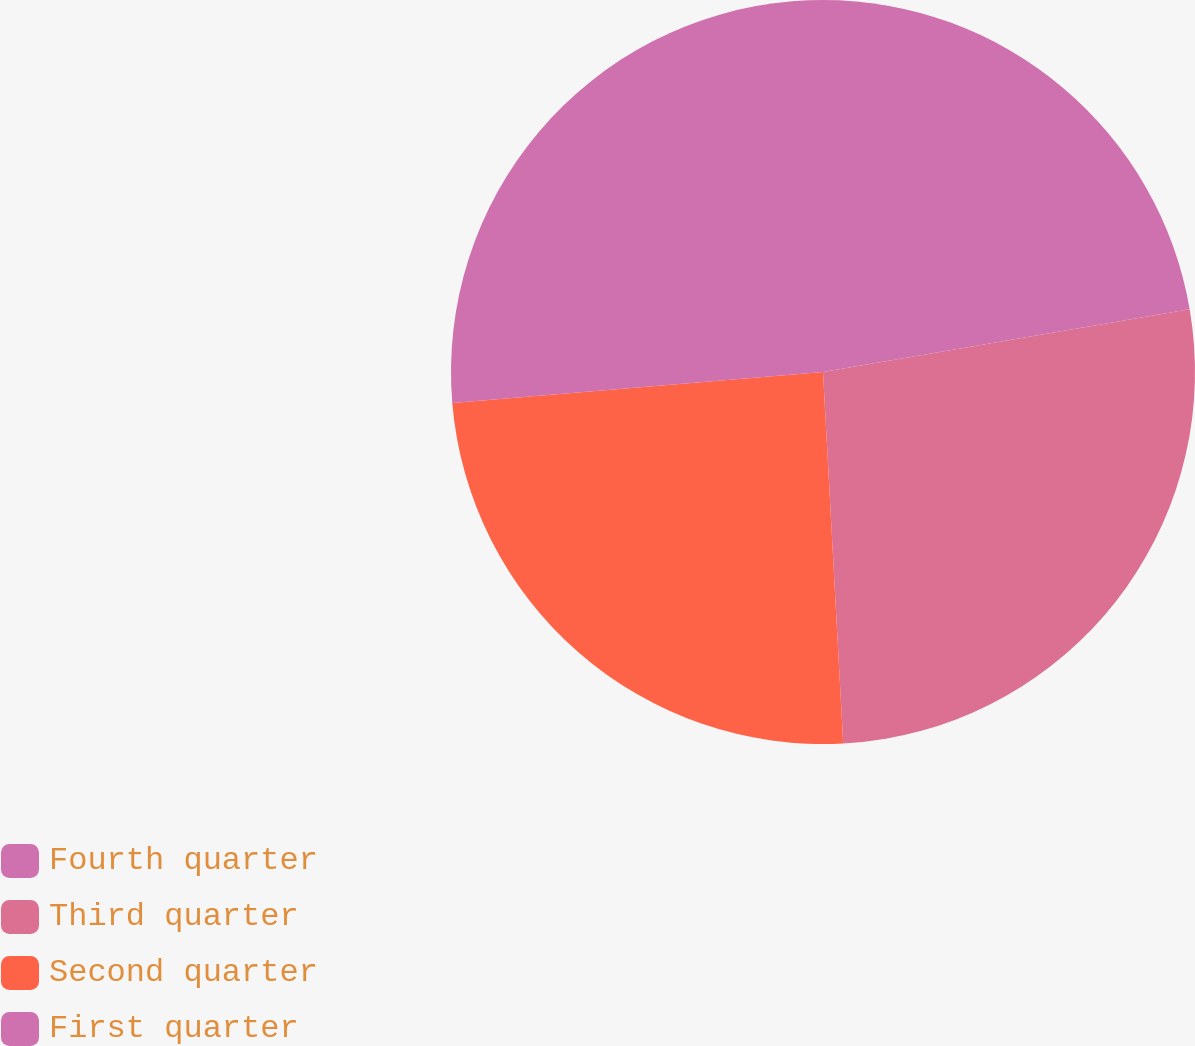<chart> <loc_0><loc_0><loc_500><loc_500><pie_chart><fcel>Fourth quarter<fcel>Third quarter<fcel>Second quarter<fcel>First quarter<nl><fcel>22.3%<fcel>26.83%<fcel>24.54%<fcel>26.32%<nl></chart> 